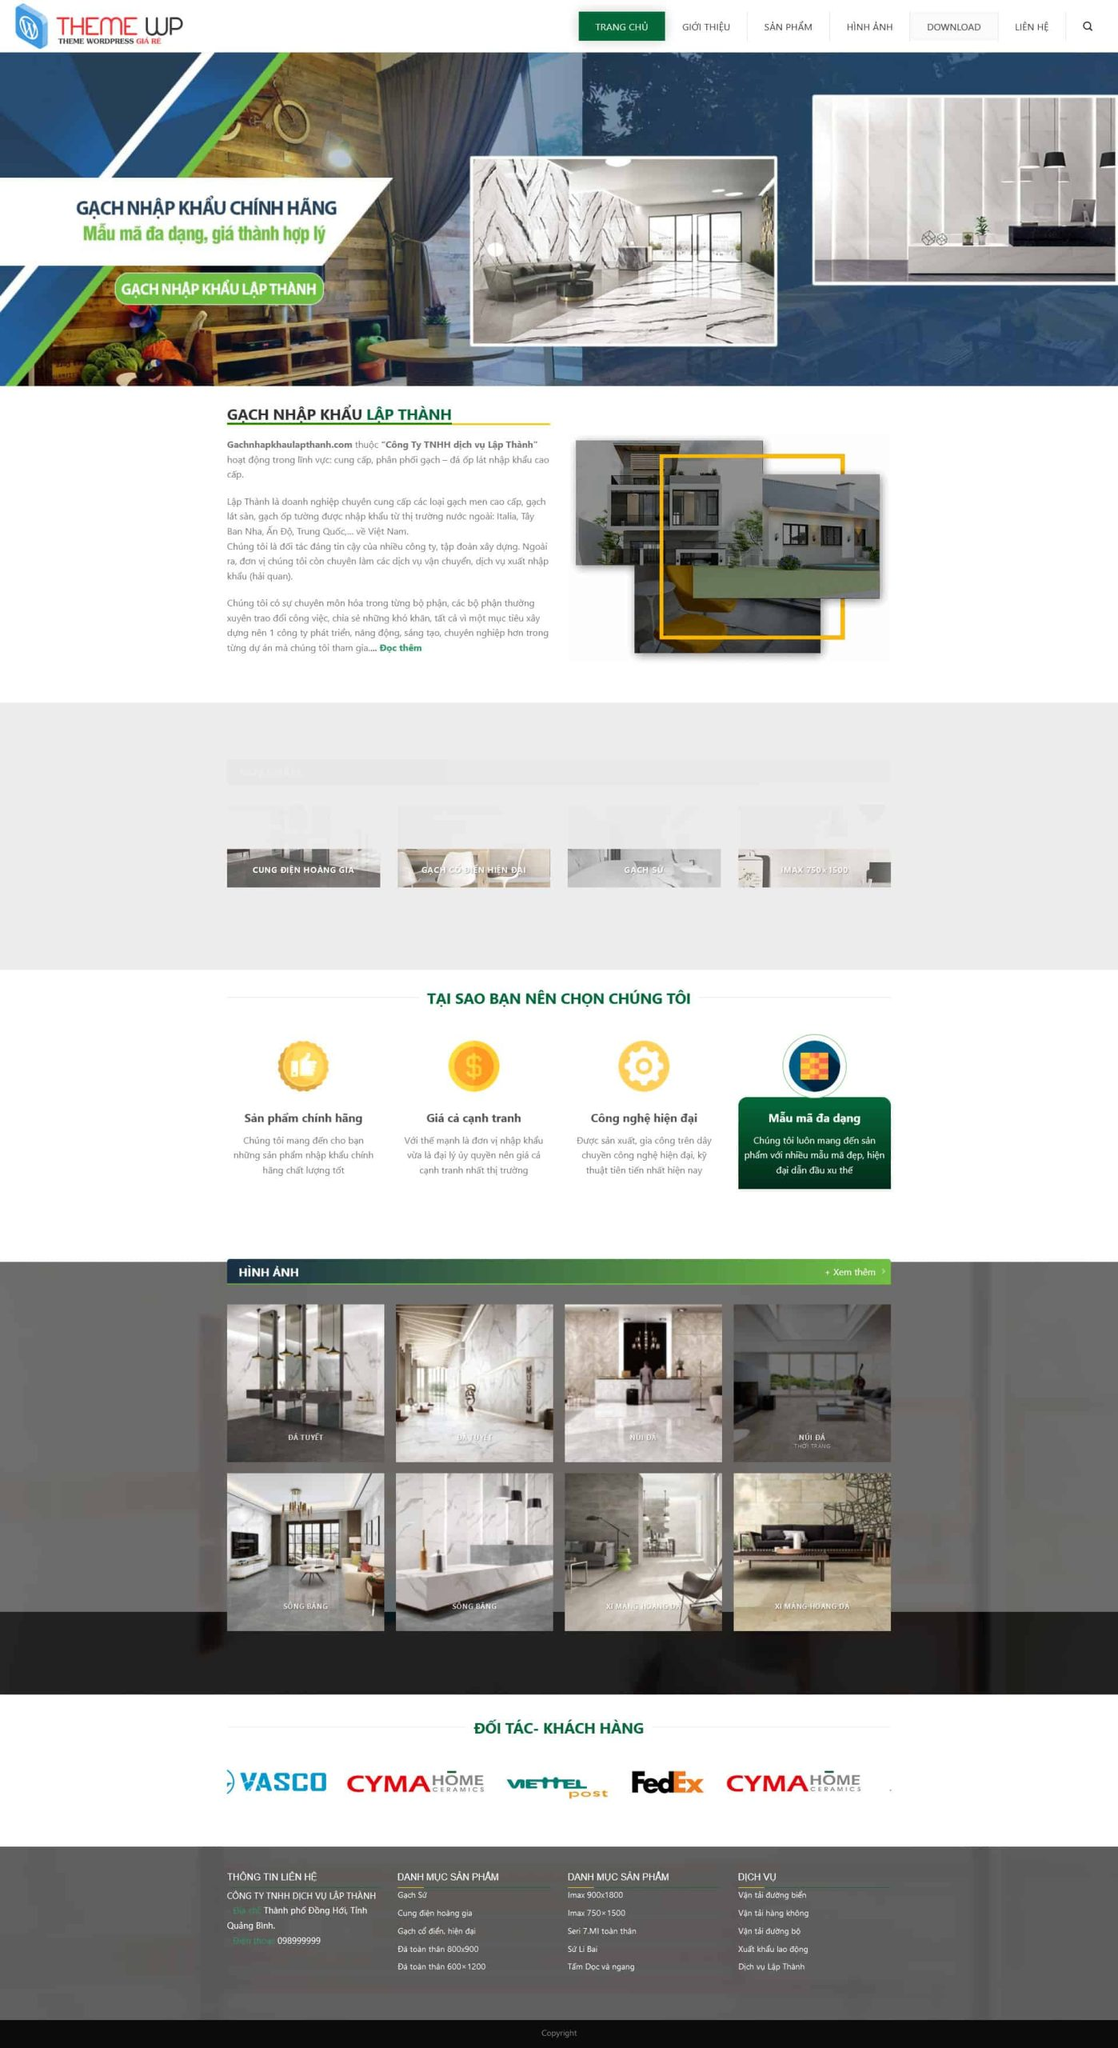Liệt kê 5 ngành nghề, lĩnh vực phù hợp với website này, phân cách các màu sắc bằng dấu phẩy. Chỉ trả về kết quả, phân cách bằng dấy phẩy
 Thiết kế nội thất, Xây dựng, Kiến trúc, Bất động sản, Vật liệu xây dựng 